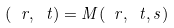<formula> <loc_0><loc_0><loc_500><loc_500>( \ r , \ t ) = M ( \ r , \ t , s )</formula> 